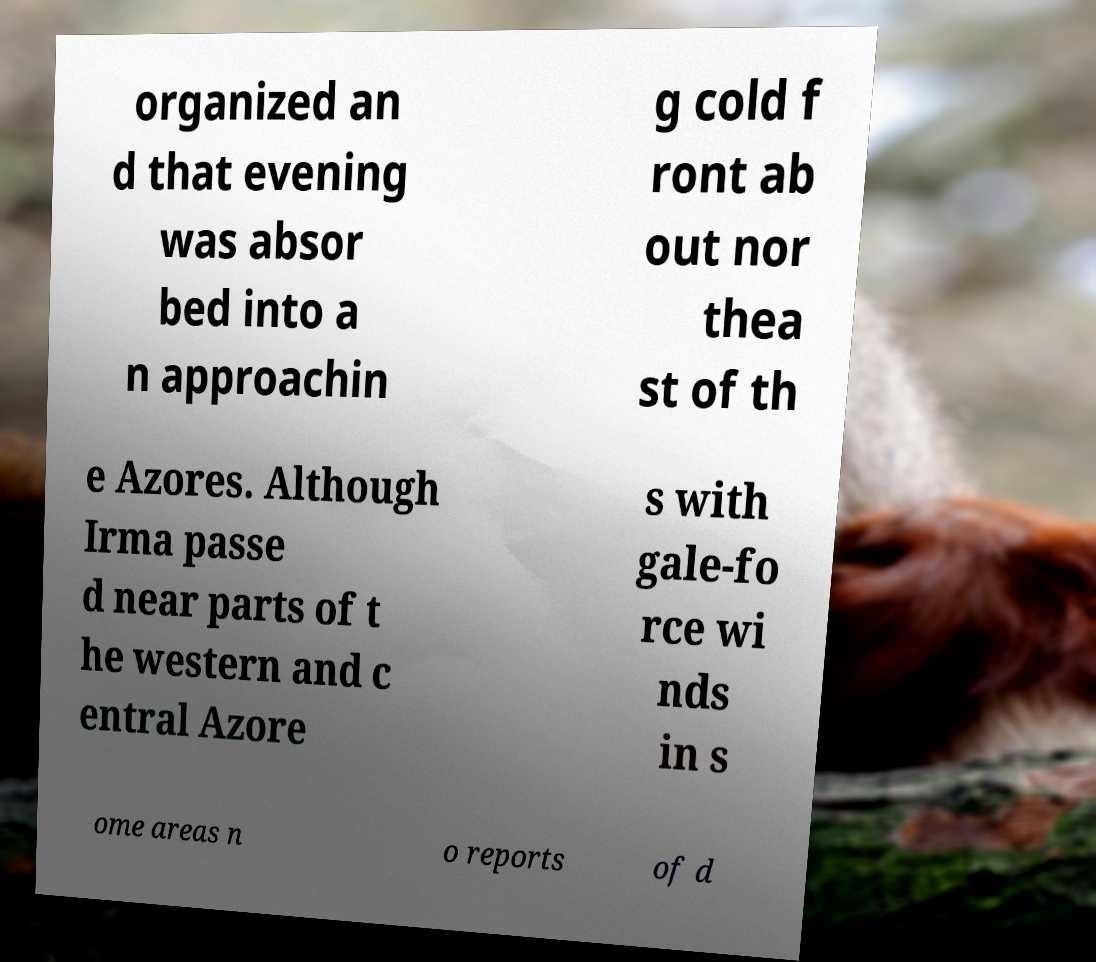Please identify and transcribe the text found in this image. organized an d that evening was absor bed into a n approachin g cold f ront ab out nor thea st of th e Azores. Although Irma passe d near parts of t he western and c entral Azore s with gale-fo rce wi nds in s ome areas n o reports of d 